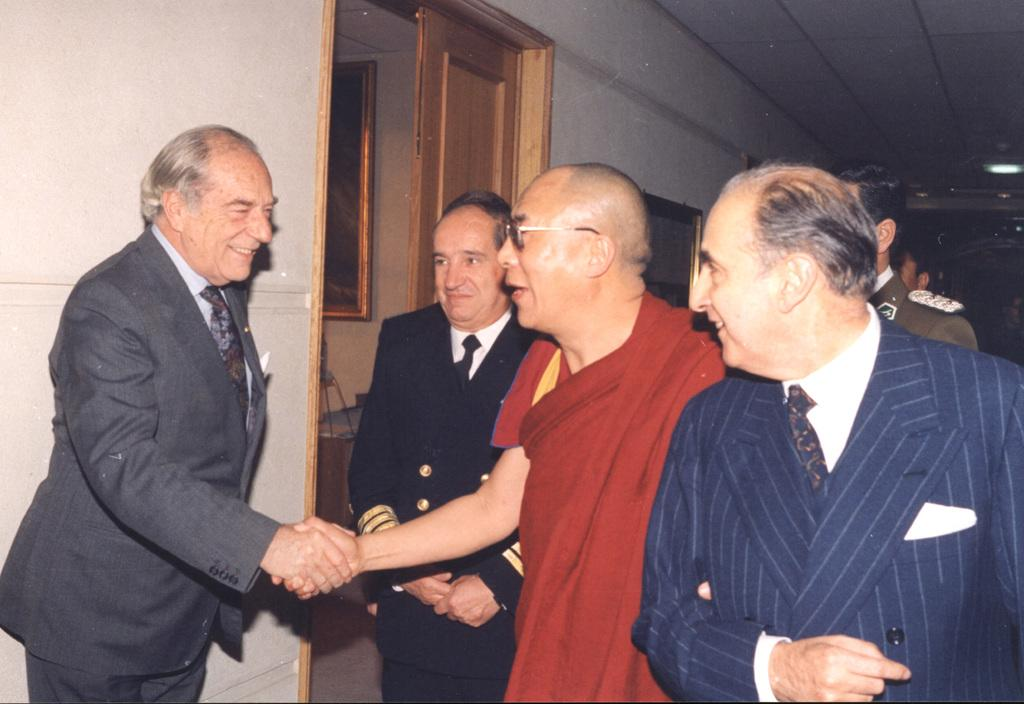What is happening between the two persons in the image? Two persons are handshaking each other in the image. How many people are present in the image? There is a group of people standing in the image. What can be seen on the wall in the background of the image? There are frames attached to the wall in the background of the image. What other objects are visible in the background of the image? There is a chair and lights in the background of the image. What type of sack is being used by the person in the image? There is no sack present in the image. What experience can be gained from the handshake in the image? The image does not convey any specific experience gained from the handshake; it simply shows two persons shaking hands. 